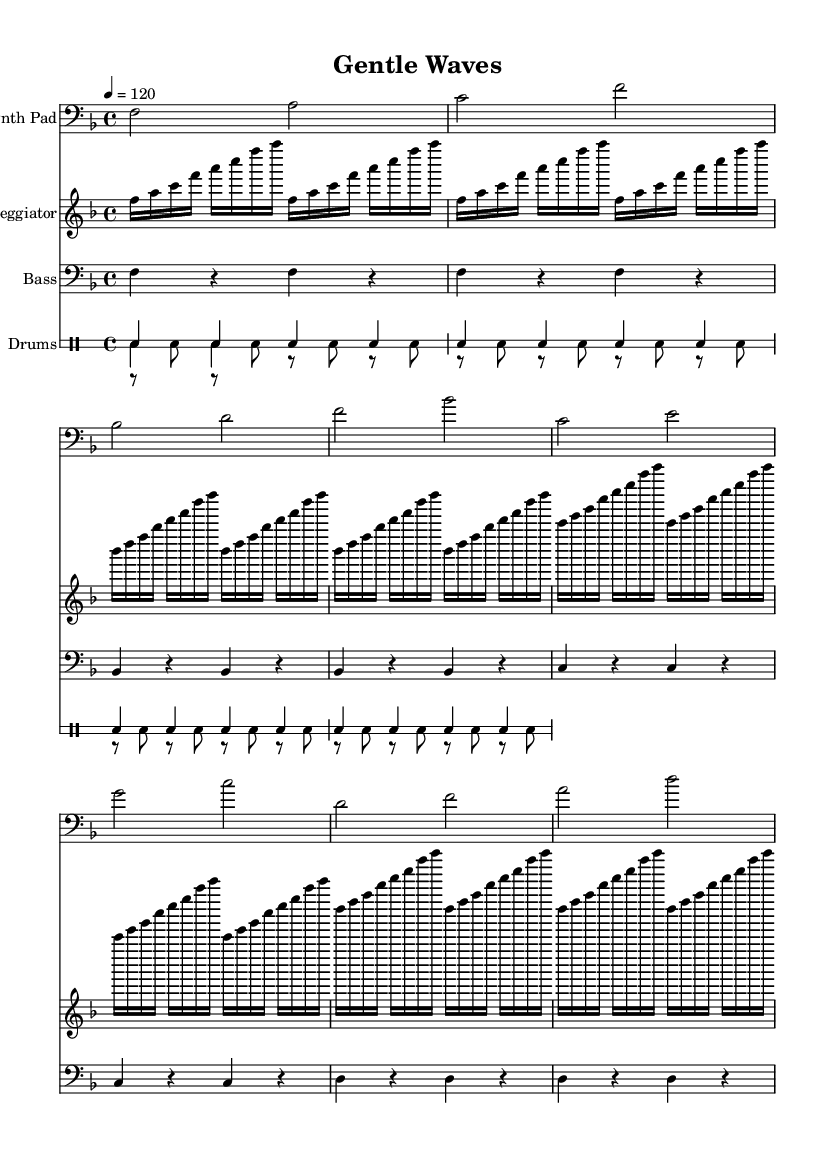What is the key signature of this music? The key signature is F major, indicated by one flat. You can identify the key signature by looking at the beginning of the staff where the flats are placed.
Answer: F major What is the time signature of this music? The time signature is 4/4, which means there are four beats in each measure and a quarter note gets one beat. This can be seen at the beginning of the piece after the clef and key signature.
Answer: 4/4 What is the tempo marking for this piece? The tempo marking is 120, which is indicated by the note "4 = 120" showing that there are 120 beats per minute. This lets the musician know how fast to play the piece.
Answer: 120 How many measures are present in the arpeggiator section? The arpeggiator section has 16 measures. You can count measures in this section by noting the series of four repeated patterns, each constituting one measure.
Answer: 16 Which instrument is featured as the lead in this piece? The lead instrument in this piece is the Synth Pad. This is specified at the beginning of the staff for that instrument.
Answer: Synth Pad What is the function of the bass in this piece? The function of the bass in this piece is to provide harmony and depth. You can determine this by looking at the bass line's rhythmic and melodic content, which supports the overall sound.
Answer: Harmony Describe the rhythmic pattern of the hi-hat. The hi-hat plays a consistent rhythm based on eighth notes. By observing the notation, you can see that it alternates with rests, maintaining a steady pulse.
Answer: Eighth notes 